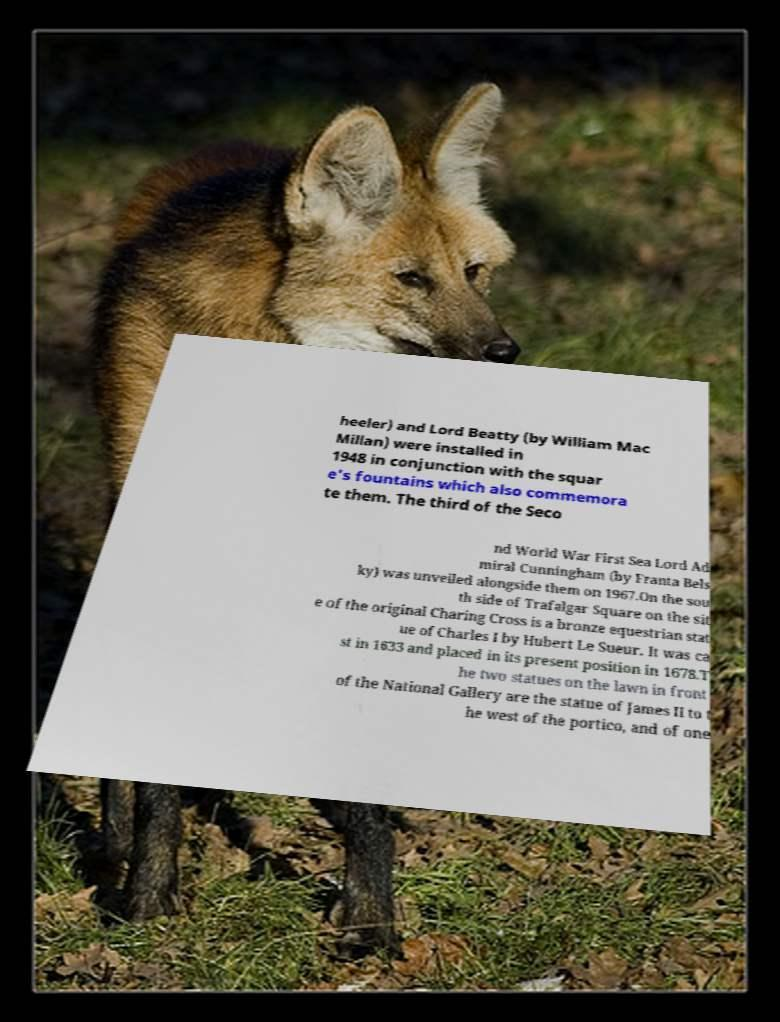Please identify and transcribe the text found in this image. heeler) and Lord Beatty (by William Mac Millan) were installed in 1948 in conjunction with the squar e's fountains which also commemora te them. The third of the Seco nd World War First Sea Lord Ad miral Cunningham (by Franta Bels ky) was unveiled alongside them on 1967.On the sou th side of Trafalgar Square on the sit e of the original Charing Cross is a bronze equestrian stat ue of Charles I by Hubert Le Sueur. It was ca st in 1633 and placed in its present position in 1678.T he two statues on the lawn in front of the National Gallery are the statue of James II to t he west of the portico, and of one 